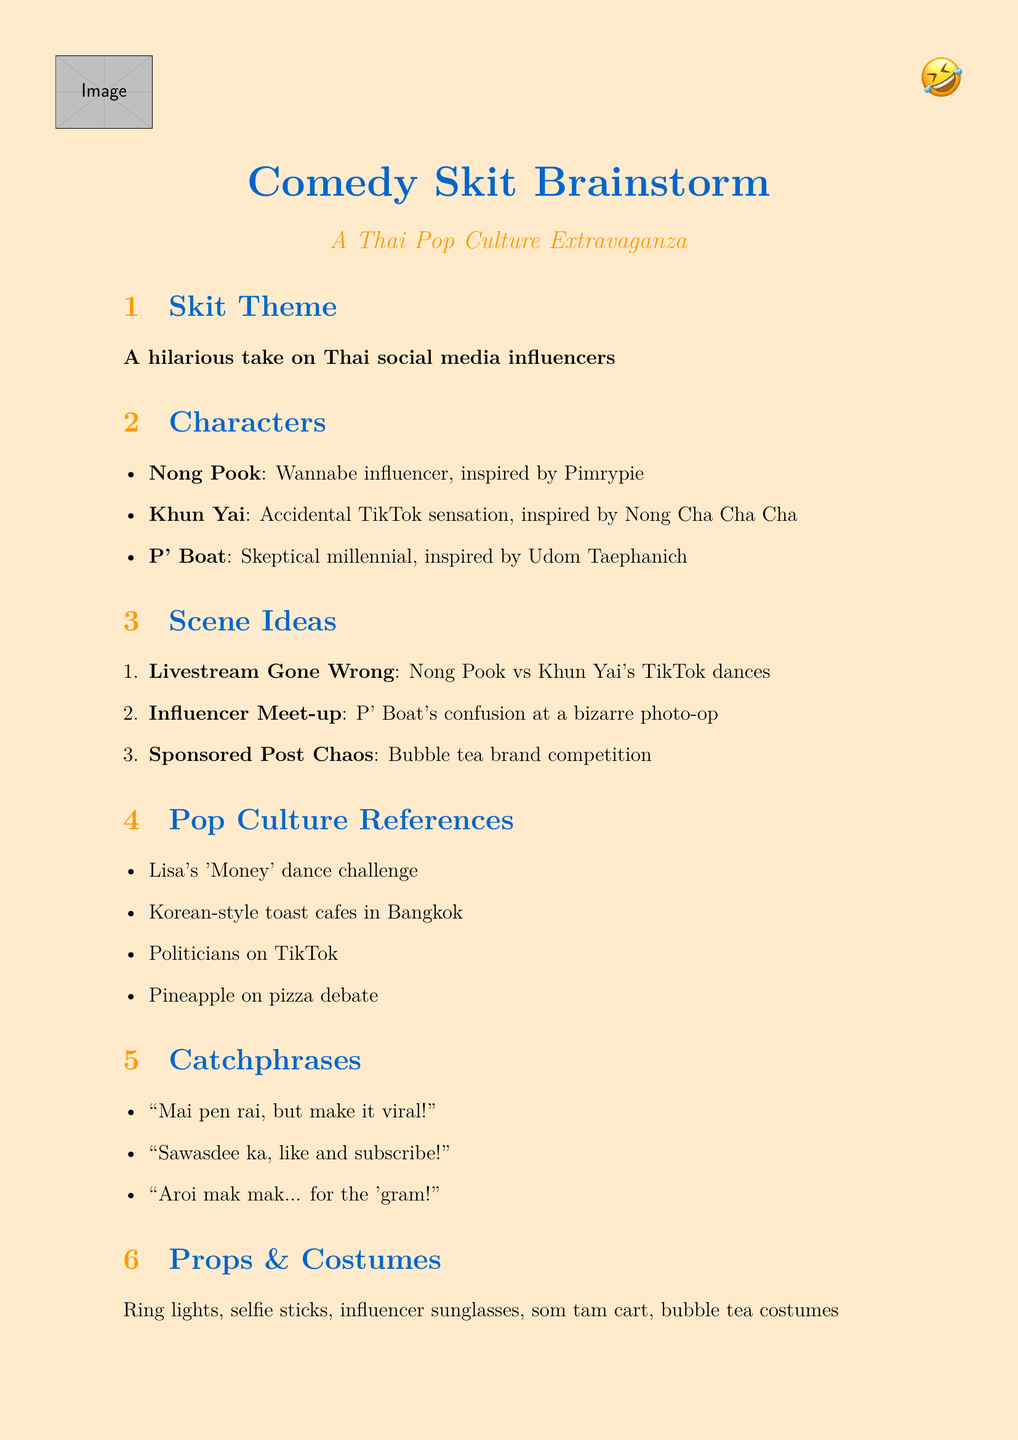What is the theme of the skit? The theme of the skit, as stated in the document, is "A hilarious take on Thai social media influencers."
Answer: A hilarious take on Thai social media influencers Who is Nong Pook inspired by? The document mentions that Nong Pook is inspired by Pimrypie, a popular Thai social media personality.
Answer: Pimrypie What is Khun Yai's accidental fame? According to the document, Khun Yai accidentally becomes a TikTok sensation.
Answer: TikTok sensation What is one pop culture reference included? The document lists references, including "Lisa from BLACKPINK's 'Money' dance challenge."
Answer: Lisa from BLACKPINK's 'Money' dance challenge How many characters are described in the document? The document describes three characters: Nong Pook, Khun Yai, and P' Boat.
Answer: Three What is one of the potential catchphrases? The document includes multiple catchphrases, one of which is "Mai pen rai, but make it viral!"
Answer: Mai pen rai, but make it viral! What type of event does P' Boat attend? The document states that P' Boat reluctantly attends an influencer event.
Answer: Influencer event What is one possible ending for the skit? The document suggests multiple endings, including Khun Yai becoming an international sensation.
Answer: Khun Yai goes Hollywood 